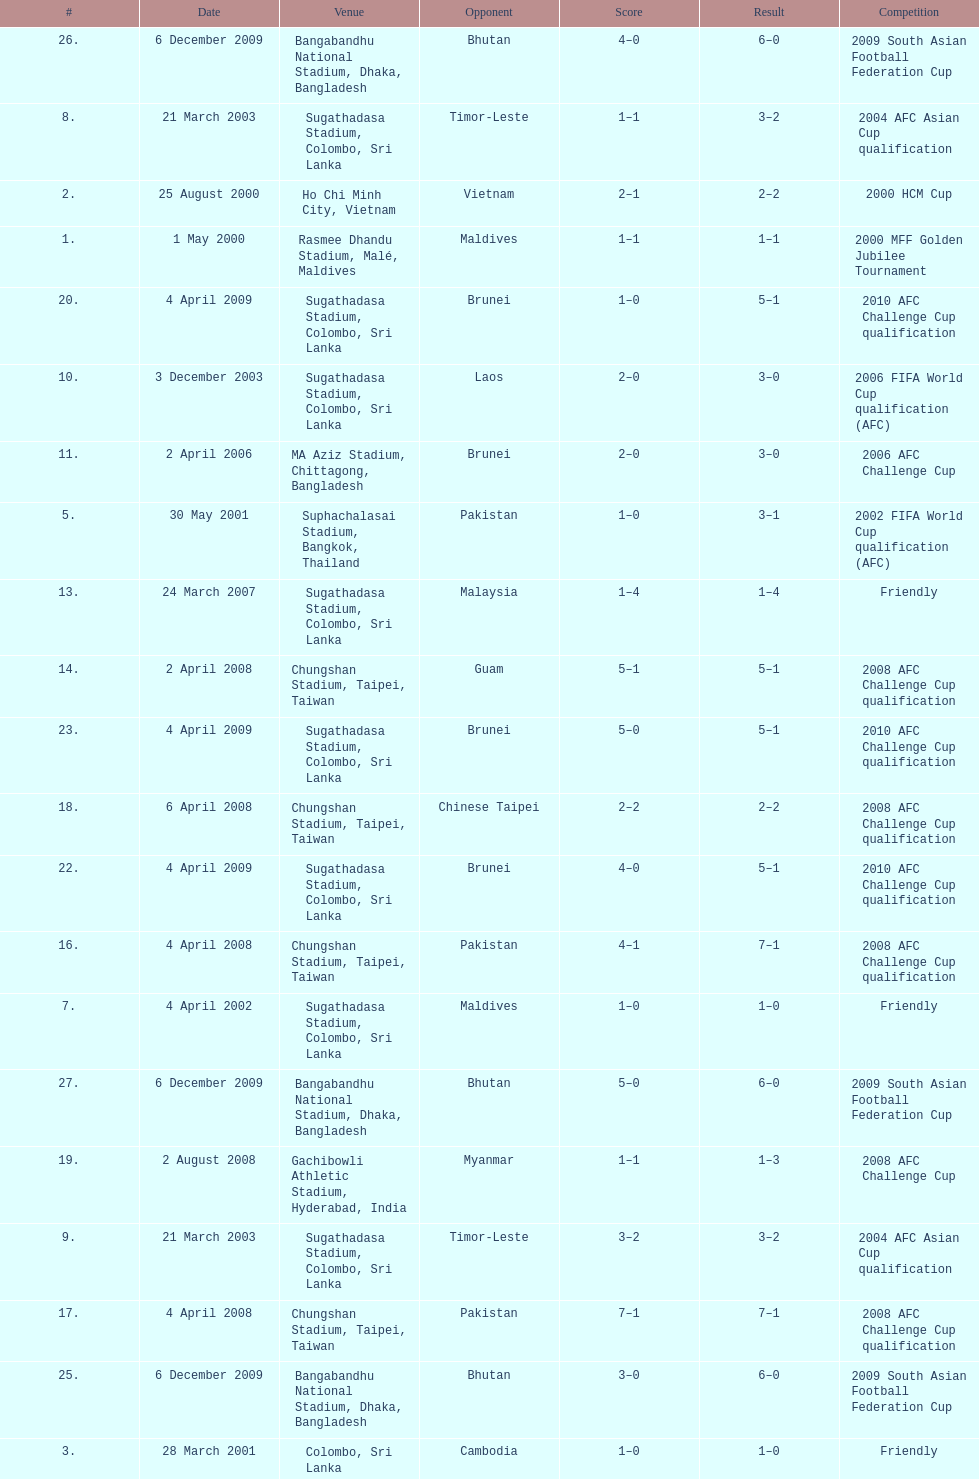In how many games did sri lanka score at least 2 goals? 16. Give me the full table as a dictionary. {'header': ['#', 'Date', 'Venue', 'Opponent', 'Score', 'Result', 'Competition'], 'rows': [['26.', '6 December 2009', 'Bangabandhu National Stadium, Dhaka, Bangladesh', 'Bhutan', '4–0', '6–0', '2009 South Asian Football Federation Cup'], ['8.', '21 March 2003', 'Sugathadasa Stadium, Colombo, Sri Lanka', 'Timor-Leste', '1–1', '3–2', '2004 AFC Asian Cup qualification'], ['2.', '25 August 2000', 'Ho Chi Minh City, Vietnam', 'Vietnam', '2–1', '2–2', '2000 HCM Cup'], ['1.', '1 May 2000', 'Rasmee Dhandu Stadium, Malé, Maldives', 'Maldives', '1–1', '1–1', '2000 MFF Golden Jubilee Tournament'], ['20.', '4 April 2009', 'Sugathadasa Stadium, Colombo, Sri Lanka', 'Brunei', '1–0', '5–1', '2010 AFC Challenge Cup qualification'], ['10.', '3 December 2003', 'Sugathadasa Stadium, Colombo, Sri Lanka', 'Laos', '2–0', '3–0', '2006 FIFA World Cup qualification (AFC)'], ['11.', '2 April 2006', 'MA Aziz Stadium, Chittagong, Bangladesh', 'Brunei', '2–0', '3–0', '2006 AFC Challenge Cup'], ['5.', '30 May 2001', 'Suphachalasai Stadium, Bangkok, Thailand', 'Pakistan', '1–0', '3–1', '2002 FIFA World Cup qualification (AFC)'], ['13.', '24 March 2007', 'Sugathadasa Stadium, Colombo, Sri Lanka', 'Malaysia', '1–4', '1–4', 'Friendly'], ['14.', '2 April 2008', 'Chungshan Stadium, Taipei, Taiwan', 'Guam', '5–1', '5–1', '2008 AFC Challenge Cup qualification'], ['23.', '4 April 2009', 'Sugathadasa Stadium, Colombo, Sri Lanka', 'Brunei', '5–0', '5–1', '2010 AFC Challenge Cup qualification'], ['18.', '6 April 2008', 'Chungshan Stadium, Taipei, Taiwan', 'Chinese Taipei', '2–2', '2–2', '2008 AFC Challenge Cup qualification'], ['22.', '4 April 2009', 'Sugathadasa Stadium, Colombo, Sri Lanka', 'Brunei', '4–0', '5–1', '2010 AFC Challenge Cup qualification'], ['16.', '4 April 2008', 'Chungshan Stadium, Taipei, Taiwan', 'Pakistan', '4–1', '7–1', '2008 AFC Challenge Cup qualification'], ['7.', '4 April 2002', 'Sugathadasa Stadium, Colombo, Sri Lanka', 'Maldives', '1–0', '1–0', 'Friendly'], ['27.', '6 December 2009', 'Bangabandhu National Stadium, Dhaka, Bangladesh', 'Bhutan', '5–0', '6–0', '2009 South Asian Football Federation Cup'], ['19.', '2 August 2008', 'Gachibowli Athletic Stadium, Hyderabad, India', 'Myanmar', '1–1', '1–3', '2008 AFC Challenge Cup'], ['9.', '21 March 2003', 'Sugathadasa Stadium, Colombo, Sri Lanka', 'Timor-Leste', '3–2', '3–2', '2004 AFC Asian Cup qualification'], ['17.', '4 April 2008', 'Chungshan Stadium, Taipei, Taiwan', 'Pakistan', '7–1', '7–1', '2008 AFC Challenge Cup qualification'], ['25.', '6 December 2009', 'Bangabandhu National Stadium, Dhaka, Bangladesh', 'Bhutan', '3–0', '6–0', '2009 South Asian Football Federation Cup'], ['3.', '28 March 2001', 'Colombo, Sri Lanka', 'Cambodia', '1–0', '1–0', 'Friendly'], ['15.', '4 April 2008', 'Chungshan Stadium, Taipei, Taiwan', 'Pakistan', '1–0', '7–1', '2008 AFC Challenge Cup qualification'], ['21.', '4 April 2009', 'Sugathadasa Stadium, Colombo, Sri Lanka', 'Brunei', '3–0', '5–1', '2010 AFC Challenge Cup qualification'], ['4.', '17 May 2001', 'Beirut Municipal Stadium, Beirut, Lebanon', 'Pakistan', '3–2', '3–3', '2002 FIFA World Cup qualification (AFC)'], ['6.', '30 May 2001', 'Supachalasai Stadium, Bangkok, Thailand', 'Pakistan', '3–0', '3–1', '2002 FIFA World Cup qualification (AFC)'], ['24.', '6 April 2009', 'Sugathadasa Stadium, Colombo, Sri Lanka', 'Chinese Taipei', '1–0', '2–1', '2010 AFC Challenge Cup qualification'], ['12.', '12 April 2006', 'MA Aziz Stadium, Chittagong, Bangladesh', 'Nepal', '1–0', '1–1', '2006 AFC Challenge Cup']]} 